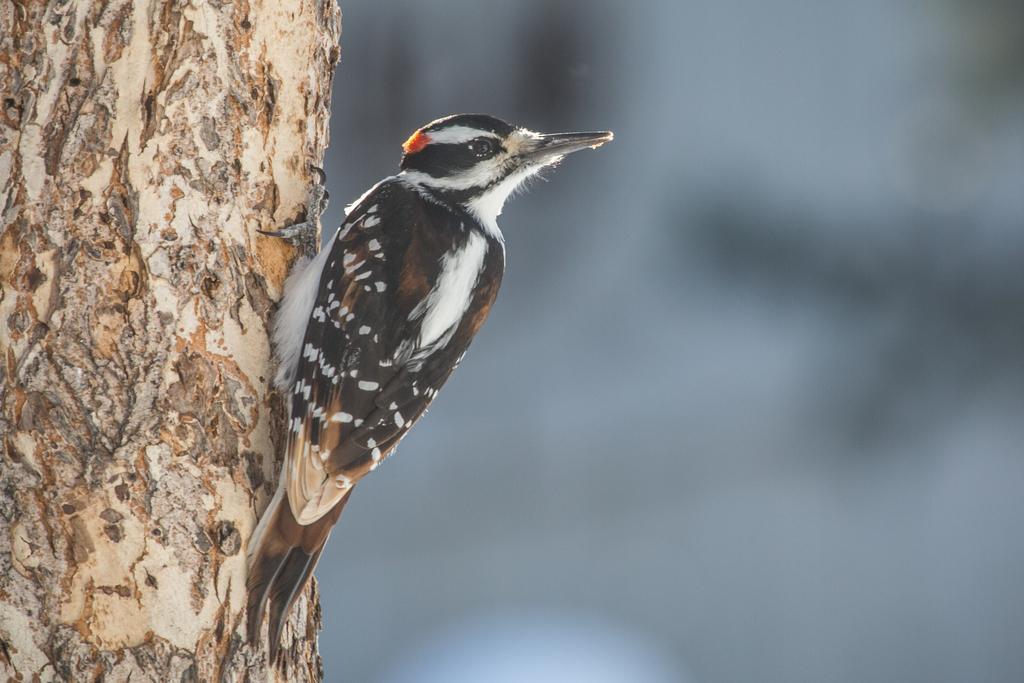Describe this image in one or two sentences. In the picture there is a bird standing by holding the tree trunk and the background is blurry. 